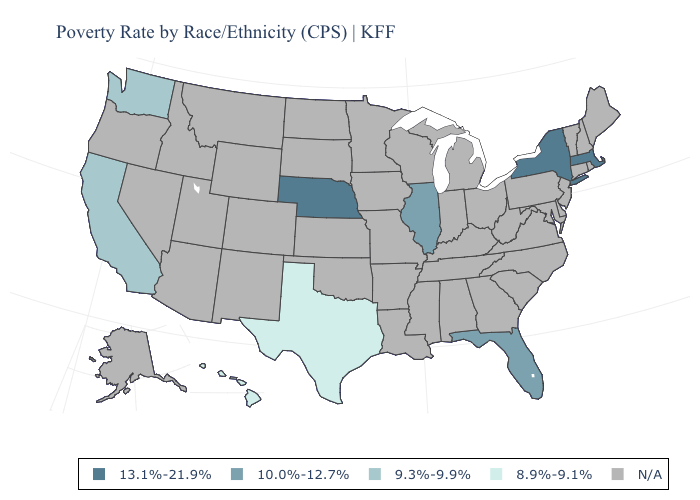What is the value of Iowa?
Write a very short answer. N/A. Name the states that have a value in the range 10.0%-12.7%?
Keep it brief. Florida, Illinois. Does Hawaii have the highest value in the USA?
Write a very short answer. No. Name the states that have a value in the range 9.3%-9.9%?
Quick response, please. California, Washington. Name the states that have a value in the range 9.3%-9.9%?
Short answer required. California, Washington. Is the legend a continuous bar?
Answer briefly. No. Name the states that have a value in the range 9.3%-9.9%?
Keep it brief. California, Washington. What is the value of Connecticut?
Concise answer only. N/A. 